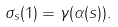<formula> <loc_0><loc_0><loc_500><loc_500>\sigma _ { s } ( 1 ) = \gamma ( \alpha ( s ) ) .</formula> 